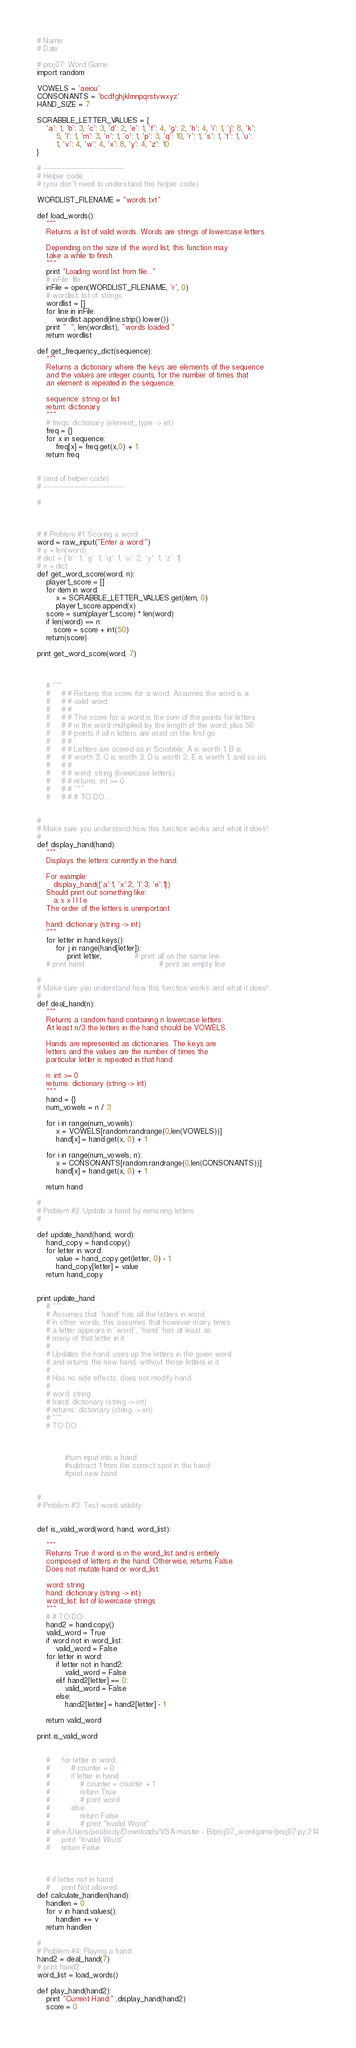Convert code to text. <code><loc_0><loc_0><loc_500><loc_500><_Python_># Name:
# Date:

# proj07: Word Game
import random

VOWELS = 'aeiou'
CONSONANTS = 'bcdfghjklmnpqrstvwxyz'
HAND_SIZE = 7

SCRABBLE_LETTER_VALUES = {
    'a': 1, 'b': 3, 'c': 3, 'd': 2, 'e': 1, 'f': 4, 'g': 2, 'h': 4, 'i': 1, 'j': 8, 'k':
        5, 'l': 1, 'm': 3, 'n': 1, 'o': 1, 'p': 3, 'q': 10, 'r': 1, 's': 1, 't': 1, 'u':
        1, 'v': 4, 'w': 4, 'x': 8, 'y': 4, 'z': 10
}

# -----------------------------------
# Helper code
# (you don't need to understand this helper code)

WORDLIST_FILENAME = "words.txt"

def load_words():
    """
    Returns a list of valid words. Words are strings of lowercase letters.
    
    Depending on the size of the word list, this function may
    take a while to finish.
    """
    print "Loading word list from file..."
    # inFile: file
    inFile = open(WORDLIST_FILENAME, 'r', 0)
    # wordlist: list of strings
    wordlist = []
    for line in inFile:
        wordlist.append(line.strip().lower())
    print "  ", len(wordlist), "words loaded."
    return wordlist

def get_frequency_dict(sequence):
    """
    Returns a dictionary where the keys are elements of the sequence
    and the values are integer counts, for the number of times that
    an element is repeated in the sequence.

    sequence: string or list
    return: dictionary
    """
    # freqs: dictionary (element_type -> int)
    freq = {}
    for x in sequence:
        freq[x] = freq.get(x,0) + 1
    return freq
	

# (end of helper code)
# -----------------------------------

#



# # Problem #1: Scoring a word
word = raw_input("Enter a word:")
# y = len(word)
# dict = {'b': 1, 'g': 1, 'q': 1, 'u': 2, 'y': 1, 'z': 1}
# n = dict
def get_word_score(word, n):
    player1_score = []
    for item in word:
        x = SCRABBLE_LETTER_VALUES.get(item, 0)
        player1_score.append(x)
    score = sum(player1_score) * len(word)
    if len(word) == n:
       score = score + int(50)
    return(score)

print get_word_score(word, 7)



    # """
    #     # # Returns the score for a word. Assumes the word is a
    #     # # valid word.
    #     # #
    #     # # The score for a word is the sum of the points for letters
    #     # # in the word multiplied by the length of the word, plus 50
    #     # # points if all n letters are used on the first go.
    #     # #
    #     # # Letters are scored as in Scrabble; A is worth 1, B is
    #     # # worth 3, C is worth 3, D is worth 2, E is worth 1, and so on.
    #     # #
    #     # # word: string (lowercase letters)
    #     # # returns: int >= 0
    #     # # """
    #     # # # TO DO...

    
#
# Make sure you understand how this function works and what it does!
#
def display_hand(hand):
    """
    Displays the letters currently in the hand.

    For example:
       display_hand({'a':1, 'x':2, 'l':3, 'e':1})
    Should print out something like:
       a x x l l l e
    The order of the letters is unimportant.

    hand: dictionary (string -> int)
    """
    for letter in hand.keys():
        for j in range(hand[letter]):
             print letter,              # print all on the same line
    # print hand                                # print an empty line

#
# Make sure you understand how this function works and what it does!
#
def deal_hand(n):
    """
    Returns a random hand containing n lowercase letters.
    At least n/3 the letters in the hand should be VOWELS.

    Hands are represented as dictionaries. The keys are
    letters and the values are the number of times the
    particular letter is repeated in that hand.

    n: int >= 0
    returns: dictionary (string -> int)
    """
    hand = {}
    num_vowels = n / 3
    
    for i in range(num_vowels):
        x = VOWELS[random.randrange(0,len(VOWELS))]
        hand[x] = hand.get(x, 0) + 1
        
    for i in range(num_vowels, n):    
        x = CONSONANTS[random.randrange(0,len(CONSONANTS))]
        hand[x] = hand.get(x, 0) + 1
        
    return hand

#
# Problem #2: Update a hand by removing letters
#

def update_hand(hand, word):
    hand_copy = hand.copy()
    for letter in word:
        value = hand_copy.get(letter, 0) - 1
        hand_copy[letter] = value
    return hand_copy


print update_hand
    # """
    # Assumes that 'hand' has all the letters in word.
    # In other words, this assumes that however many times
    # a letter appears in 'word', 'hand' has at least as
    # many of that letter in it.
    #
    # Updates the hand: uses up the letters in the given word
    # and returns the new hand, without those letters in it.
    #
    # Has no side effects: does not modify hand.
    #
    # word: string
    # hand: dictionary (string -> int)
    # returns: dictionary (string -> int)
    # """
    # TO DO ...



            #turn input into a hand
            #subtract 1 from the correct spot in the hand
            #print new hand


#
# Problem #3: Test word validity


def is_valid_word(word, hand, word_list):

    """
    Returns True if word is in the word_list and is entirely
    composed of letters in the hand. Otherwise, returns False.
    Does not mutate hand or word_list.
    
    word: string
    hand: dictionary (string -> int)
    word_list: list of lowercase strings
    """
    # # TO DO...
    hand2 = hand.copy()
    valid_word = True
    if word not in word_list:
        valid_word = False
    for letter in word:
        if letter not in hand2:
            valid_word = False
        elif hand2[letter] == 0:
            valid_word = False
        else:
            hand2[letter] = hand2[letter] - 1

    return valid_word

print is_valid_word


    #     for letter in word:
    #         # counter = 0
    #         if letter in hand:
    #             # counter = counter + 1
    #             return True
    #             # print word
    #         else:
    #             return False
    #             # print "Invalid Word"
    # else:/Users/peabody/Downloads/VSA-master - B/proj07_wordgame/proj07.py:214
    #     print "Invalid Word"
    #     return False



    # if letter not in hand:
    #     print Not allowed
def calculate_handlen(hand):
    handlen = 0
    for v in hand.values():
        handlen += v
    return handlen

#
# Problem #4: Playing a hand
hand2 = deal_hand(7)
# print hand2
word_list = load_words()

def play_hand(hand2):
    print "Current Hand:" ,display_hand(hand2)
    score = 0</code> 